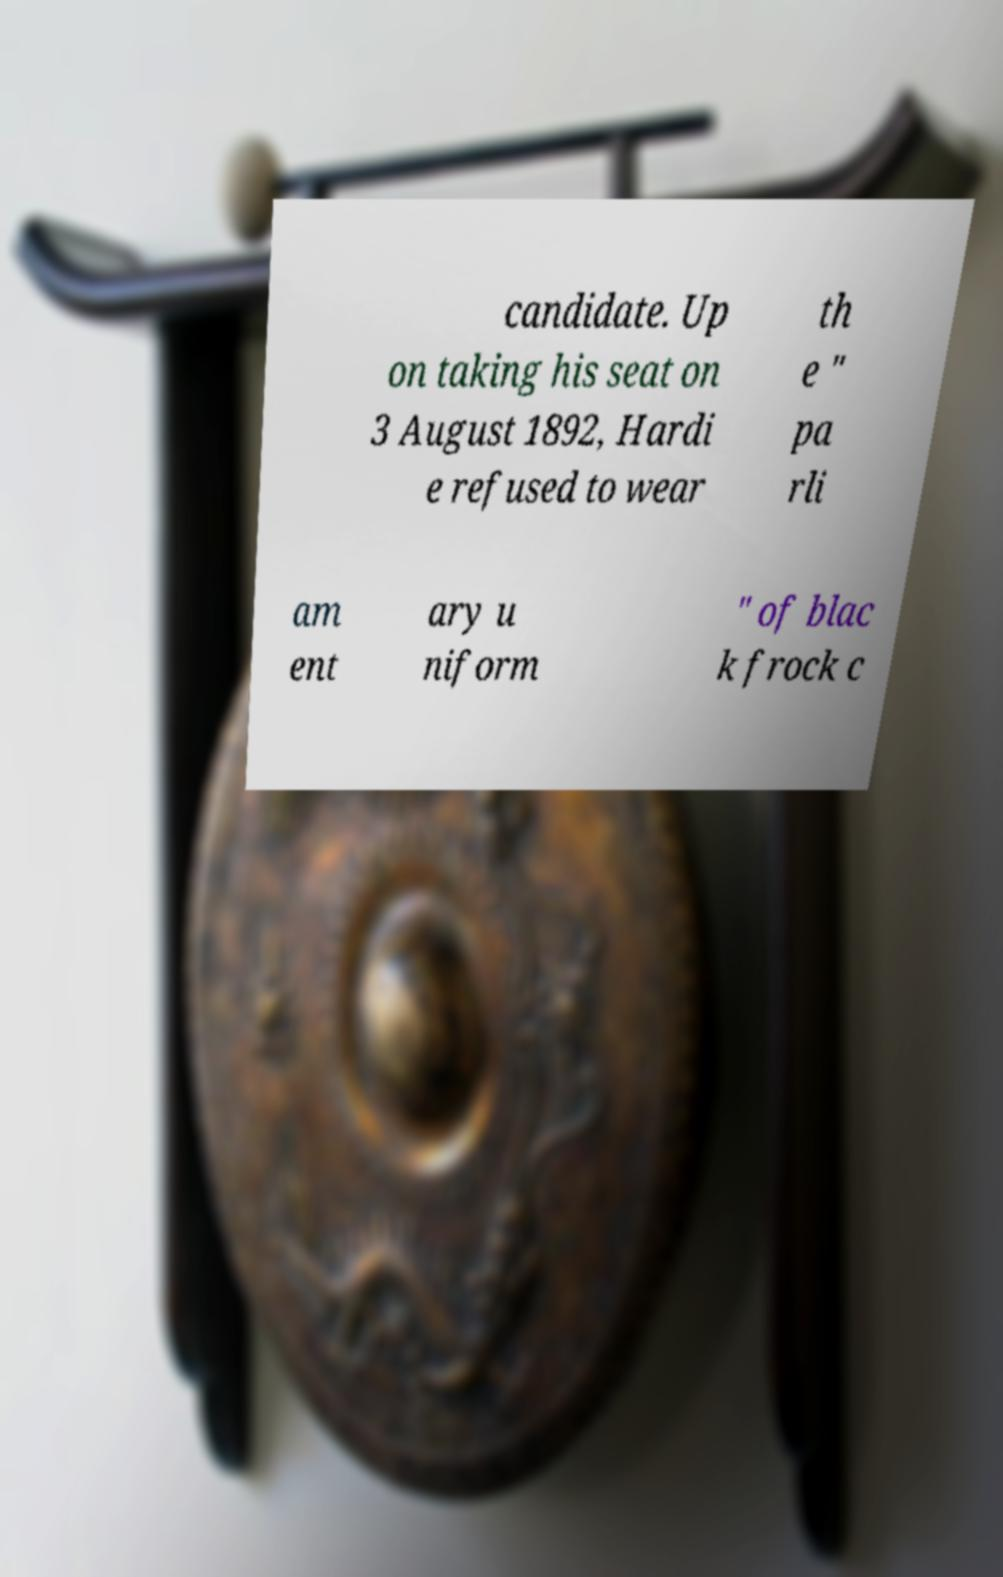Can you accurately transcribe the text from the provided image for me? candidate. Up on taking his seat on 3 August 1892, Hardi e refused to wear th e " pa rli am ent ary u niform " of blac k frock c 